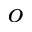Convert formula to latex. <formula><loc_0><loc_0><loc_500><loc_500>^ { o }</formula> 